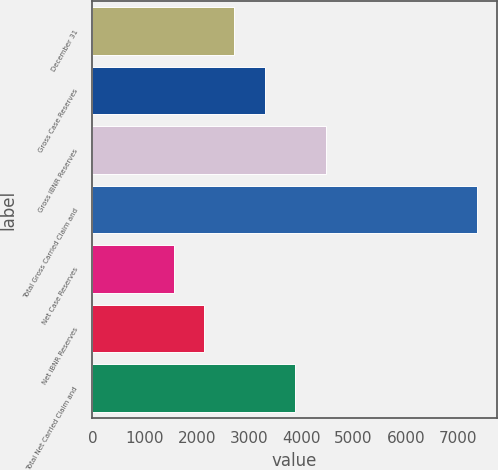Convert chart. <chart><loc_0><loc_0><loc_500><loc_500><bar_chart><fcel>December 31<fcel>Gross Case Reserves<fcel>Gross IBNR Reserves<fcel>Total Gross Carried Claim and<fcel>Net Case Reserves<fcel>Net IBNR Reserves<fcel>Total Net Carried Claim and<nl><fcel>2717.6<fcel>3299.4<fcel>4463<fcel>7372<fcel>1554<fcel>2135.8<fcel>3881.2<nl></chart> 